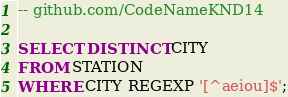<code> <loc_0><loc_0><loc_500><loc_500><_SQL_>-- github.com/CodeNameKND14

SELECT DISTINCT CITY 
FROM STATION
WHERE CITY REGEXP '[^aeiou]$';
</code> 